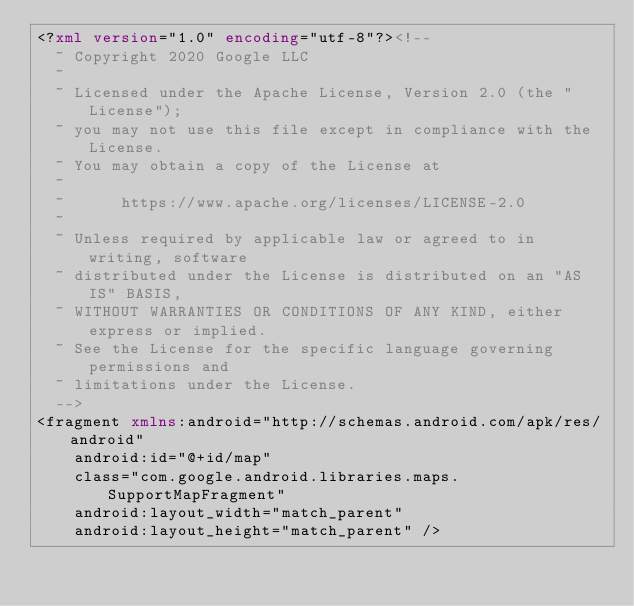<code> <loc_0><loc_0><loc_500><loc_500><_XML_><?xml version="1.0" encoding="utf-8"?><!--
  ~ Copyright 2020 Google LLC
  ~
  ~ Licensed under the Apache License, Version 2.0 (the "License");
  ~ you may not use this file except in compliance with the License.
  ~ You may obtain a copy of the License at
  ~
  ~      https://www.apache.org/licenses/LICENSE-2.0
  ~
  ~ Unless required by applicable law or agreed to in writing, software
  ~ distributed under the License is distributed on an "AS IS" BASIS,
  ~ WITHOUT WARRANTIES OR CONDITIONS OF ANY KIND, either express or implied.
  ~ See the License for the specific language governing permissions and
  ~ limitations under the License.
  -->
<fragment xmlns:android="http://schemas.android.com/apk/res/android"
    android:id="@+id/map"
    class="com.google.android.libraries.maps.SupportMapFragment"
    android:layout_width="match_parent"
    android:layout_height="match_parent" />
</code> 